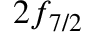<formula> <loc_0><loc_0><loc_500><loc_500>2 f _ { 7 / 2 }</formula> 